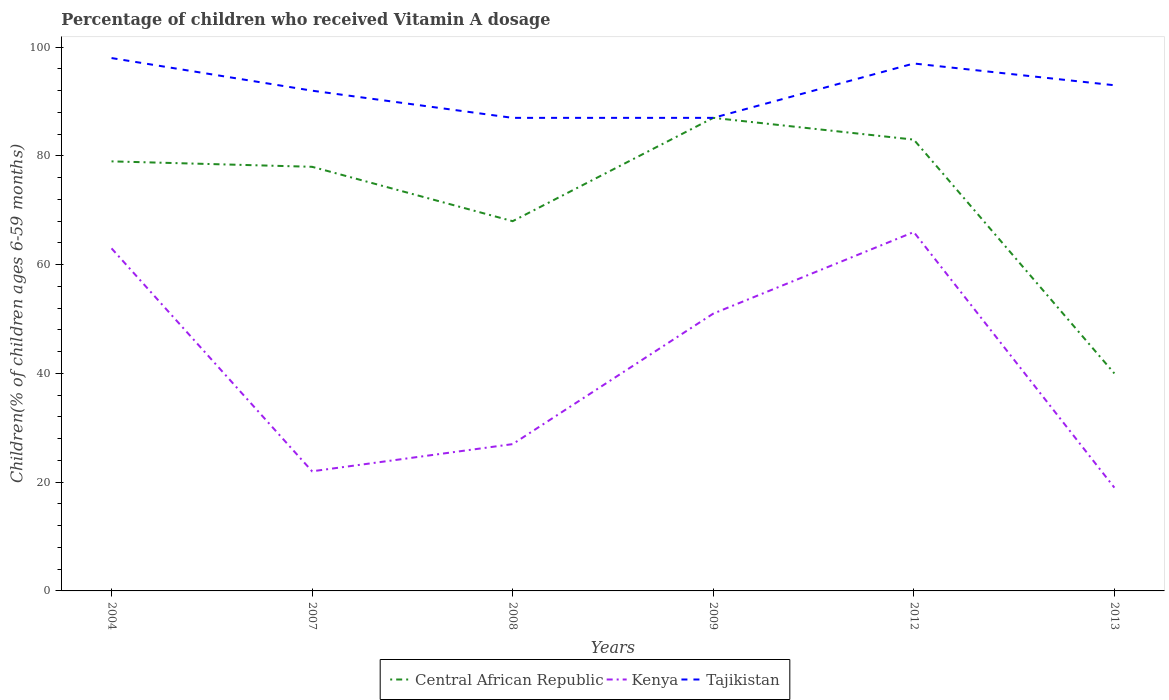How many different coloured lines are there?
Make the answer very short. 3. Does the line corresponding to Tajikistan intersect with the line corresponding to Kenya?
Keep it short and to the point. No. Is the number of lines equal to the number of legend labels?
Provide a short and direct response. Yes. What is the total percentage of children who received Vitamin A dosage in Central African Republic in the graph?
Offer a terse response. 10. What is the difference between the highest and the second highest percentage of children who received Vitamin A dosage in Central African Republic?
Your response must be concise. 47. What is the difference between the highest and the lowest percentage of children who received Vitamin A dosage in Kenya?
Provide a short and direct response. 3. Does the graph contain grids?
Provide a short and direct response. No. Where does the legend appear in the graph?
Your answer should be very brief. Bottom center. What is the title of the graph?
Keep it short and to the point. Percentage of children who received Vitamin A dosage. Does "Malta" appear as one of the legend labels in the graph?
Give a very brief answer. No. What is the label or title of the Y-axis?
Provide a short and direct response. Children(% of children ages 6-59 months). What is the Children(% of children ages 6-59 months) of Central African Republic in 2004?
Your answer should be compact. 79. What is the Children(% of children ages 6-59 months) of Kenya in 2004?
Ensure brevity in your answer.  63. What is the Children(% of children ages 6-59 months) in Kenya in 2007?
Provide a short and direct response. 22. What is the Children(% of children ages 6-59 months) in Tajikistan in 2007?
Make the answer very short. 92. What is the Children(% of children ages 6-59 months) of Central African Republic in 2008?
Your answer should be compact. 68. What is the Children(% of children ages 6-59 months) in Kenya in 2008?
Ensure brevity in your answer.  27. What is the Children(% of children ages 6-59 months) of Tajikistan in 2008?
Offer a terse response. 87. What is the Children(% of children ages 6-59 months) in Central African Republic in 2009?
Provide a succinct answer. 87. What is the Children(% of children ages 6-59 months) in Kenya in 2009?
Your response must be concise. 51. What is the Children(% of children ages 6-59 months) in Kenya in 2012?
Keep it short and to the point. 66. What is the Children(% of children ages 6-59 months) in Tajikistan in 2012?
Give a very brief answer. 97. What is the Children(% of children ages 6-59 months) in Kenya in 2013?
Provide a short and direct response. 19. What is the Children(% of children ages 6-59 months) of Tajikistan in 2013?
Provide a succinct answer. 93. Across all years, what is the maximum Children(% of children ages 6-59 months) of Kenya?
Offer a terse response. 66. Across all years, what is the maximum Children(% of children ages 6-59 months) of Tajikistan?
Your answer should be compact. 98. Across all years, what is the minimum Children(% of children ages 6-59 months) of Kenya?
Your response must be concise. 19. Across all years, what is the minimum Children(% of children ages 6-59 months) in Tajikistan?
Your answer should be compact. 87. What is the total Children(% of children ages 6-59 months) in Central African Republic in the graph?
Give a very brief answer. 435. What is the total Children(% of children ages 6-59 months) of Kenya in the graph?
Your answer should be compact. 248. What is the total Children(% of children ages 6-59 months) in Tajikistan in the graph?
Provide a succinct answer. 554. What is the difference between the Children(% of children ages 6-59 months) of Central African Republic in 2004 and that in 2008?
Offer a very short reply. 11. What is the difference between the Children(% of children ages 6-59 months) in Tajikistan in 2004 and that in 2008?
Your response must be concise. 11. What is the difference between the Children(% of children ages 6-59 months) of Kenya in 2004 and that in 2009?
Your answer should be compact. 12. What is the difference between the Children(% of children ages 6-59 months) in Central African Republic in 2004 and that in 2012?
Offer a very short reply. -4. What is the difference between the Children(% of children ages 6-59 months) of Central African Republic in 2007 and that in 2008?
Make the answer very short. 10. What is the difference between the Children(% of children ages 6-59 months) of Kenya in 2007 and that in 2008?
Keep it short and to the point. -5. What is the difference between the Children(% of children ages 6-59 months) in Tajikistan in 2007 and that in 2008?
Your response must be concise. 5. What is the difference between the Children(% of children ages 6-59 months) of Kenya in 2007 and that in 2009?
Your answer should be compact. -29. What is the difference between the Children(% of children ages 6-59 months) of Central African Republic in 2007 and that in 2012?
Offer a terse response. -5. What is the difference between the Children(% of children ages 6-59 months) of Kenya in 2007 and that in 2012?
Ensure brevity in your answer.  -44. What is the difference between the Children(% of children ages 6-59 months) in Tajikistan in 2007 and that in 2012?
Keep it short and to the point. -5. What is the difference between the Children(% of children ages 6-59 months) in Kenya in 2007 and that in 2013?
Your response must be concise. 3. What is the difference between the Children(% of children ages 6-59 months) in Kenya in 2008 and that in 2009?
Your answer should be compact. -24. What is the difference between the Children(% of children ages 6-59 months) in Tajikistan in 2008 and that in 2009?
Your response must be concise. 0. What is the difference between the Children(% of children ages 6-59 months) in Kenya in 2008 and that in 2012?
Provide a succinct answer. -39. What is the difference between the Children(% of children ages 6-59 months) in Kenya in 2008 and that in 2013?
Ensure brevity in your answer.  8. What is the difference between the Children(% of children ages 6-59 months) in Central African Republic in 2009 and that in 2012?
Provide a short and direct response. 4. What is the difference between the Children(% of children ages 6-59 months) of Kenya in 2009 and that in 2012?
Make the answer very short. -15. What is the difference between the Children(% of children ages 6-59 months) of Tajikistan in 2009 and that in 2013?
Offer a terse response. -6. What is the difference between the Children(% of children ages 6-59 months) of Central African Republic in 2012 and that in 2013?
Make the answer very short. 43. What is the difference between the Children(% of children ages 6-59 months) of Tajikistan in 2012 and that in 2013?
Keep it short and to the point. 4. What is the difference between the Children(% of children ages 6-59 months) of Central African Republic in 2004 and the Children(% of children ages 6-59 months) of Kenya in 2007?
Offer a terse response. 57. What is the difference between the Children(% of children ages 6-59 months) of Central African Republic in 2004 and the Children(% of children ages 6-59 months) of Tajikistan in 2007?
Offer a very short reply. -13. What is the difference between the Children(% of children ages 6-59 months) of Kenya in 2004 and the Children(% of children ages 6-59 months) of Tajikistan in 2008?
Make the answer very short. -24. What is the difference between the Children(% of children ages 6-59 months) in Central African Republic in 2004 and the Children(% of children ages 6-59 months) in Kenya in 2009?
Your answer should be very brief. 28. What is the difference between the Children(% of children ages 6-59 months) of Kenya in 2004 and the Children(% of children ages 6-59 months) of Tajikistan in 2009?
Provide a short and direct response. -24. What is the difference between the Children(% of children ages 6-59 months) of Central African Republic in 2004 and the Children(% of children ages 6-59 months) of Kenya in 2012?
Your response must be concise. 13. What is the difference between the Children(% of children ages 6-59 months) in Central African Republic in 2004 and the Children(% of children ages 6-59 months) in Tajikistan in 2012?
Your answer should be compact. -18. What is the difference between the Children(% of children ages 6-59 months) in Kenya in 2004 and the Children(% of children ages 6-59 months) in Tajikistan in 2012?
Offer a very short reply. -34. What is the difference between the Children(% of children ages 6-59 months) of Central African Republic in 2004 and the Children(% of children ages 6-59 months) of Kenya in 2013?
Ensure brevity in your answer.  60. What is the difference between the Children(% of children ages 6-59 months) of Central African Republic in 2007 and the Children(% of children ages 6-59 months) of Kenya in 2008?
Make the answer very short. 51. What is the difference between the Children(% of children ages 6-59 months) of Kenya in 2007 and the Children(% of children ages 6-59 months) of Tajikistan in 2008?
Your response must be concise. -65. What is the difference between the Children(% of children ages 6-59 months) of Central African Republic in 2007 and the Children(% of children ages 6-59 months) of Tajikistan in 2009?
Offer a very short reply. -9. What is the difference between the Children(% of children ages 6-59 months) in Kenya in 2007 and the Children(% of children ages 6-59 months) in Tajikistan in 2009?
Keep it short and to the point. -65. What is the difference between the Children(% of children ages 6-59 months) in Central African Republic in 2007 and the Children(% of children ages 6-59 months) in Kenya in 2012?
Offer a terse response. 12. What is the difference between the Children(% of children ages 6-59 months) in Kenya in 2007 and the Children(% of children ages 6-59 months) in Tajikistan in 2012?
Your response must be concise. -75. What is the difference between the Children(% of children ages 6-59 months) in Central African Republic in 2007 and the Children(% of children ages 6-59 months) in Tajikistan in 2013?
Keep it short and to the point. -15. What is the difference between the Children(% of children ages 6-59 months) of Kenya in 2007 and the Children(% of children ages 6-59 months) of Tajikistan in 2013?
Your response must be concise. -71. What is the difference between the Children(% of children ages 6-59 months) in Central African Republic in 2008 and the Children(% of children ages 6-59 months) in Tajikistan in 2009?
Your answer should be very brief. -19. What is the difference between the Children(% of children ages 6-59 months) of Kenya in 2008 and the Children(% of children ages 6-59 months) of Tajikistan in 2009?
Offer a terse response. -60. What is the difference between the Children(% of children ages 6-59 months) in Kenya in 2008 and the Children(% of children ages 6-59 months) in Tajikistan in 2012?
Provide a short and direct response. -70. What is the difference between the Children(% of children ages 6-59 months) of Central African Republic in 2008 and the Children(% of children ages 6-59 months) of Kenya in 2013?
Your answer should be very brief. 49. What is the difference between the Children(% of children ages 6-59 months) of Central African Republic in 2008 and the Children(% of children ages 6-59 months) of Tajikistan in 2013?
Give a very brief answer. -25. What is the difference between the Children(% of children ages 6-59 months) in Kenya in 2008 and the Children(% of children ages 6-59 months) in Tajikistan in 2013?
Your answer should be very brief. -66. What is the difference between the Children(% of children ages 6-59 months) in Central African Republic in 2009 and the Children(% of children ages 6-59 months) in Kenya in 2012?
Offer a very short reply. 21. What is the difference between the Children(% of children ages 6-59 months) of Central African Republic in 2009 and the Children(% of children ages 6-59 months) of Tajikistan in 2012?
Make the answer very short. -10. What is the difference between the Children(% of children ages 6-59 months) in Kenya in 2009 and the Children(% of children ages 6-59 months) in Tajikistan in 2012?
Ensure brevity in your answer.  -46. What is the difference between the Children(% of children ages 6-59 months) in Kenya in 2009 and the Children(% of children ages 6-59 months) in Tajikistan in 2013?
Ensure brevity in your answer.  -42. What is the difference between the Children(% of children ages 6-59 months) in Central African Republic in 2012 and the Children(% of children ages 6-59 months) in Tajikistan in 2013?
Offer a very short reply. -10. What is the difference between the Children(% of children ages 6-59 months) of Kenya in 2012 and the Children(% of children ages 6-59 months) of Tajikistan in 2013?
Your answer should be very brief. -27. What is the average Children(% of children ages 6-59 months) in Central African Republic per year?
Your response must be concise. 72.5. What is the average Children(% of children ages 6-59 months) in Kenya per year?
Ensure brevity in your answer.  41.33. What is the average Children(% of children ages 6-59 months) of Tajikistan per year?
Your answer should be compact. 92.33. In the year 2004, what is the difference between the Children(% of children ages 6-59 months) in Central African Republic and Children(% of children ages 6-59 months) in Kenya?
Offer a terse response. 16. In the year 2004, what is the difference between the Children(% of children ages 6-59 months) of Kenya and Children(% of children ages 6-59 months) of Tajikistan?
Your answer should be compact. -35. In the year 2007, what is the difference between the Children(% of children ages 6-59 months) in Kenya and Children(% of children ages 6-59 months) in Tajikistan?
Provide a succinct answer. -70. In the year 2008, what is the difference between the Children(% of children ages 6-59 months) of Kenya and Children(% of children ages 6-59 months) of Tajikistan?
Give a very brief answer. -60. In the year 2009, what is the difference between the Children(% of children ages 6-59 months) of Central African Republic and Children(% of children ages 6-59 months) of Tajikistan?
Provide a short and direct response. 0. In the year 2009, what is the difference between the Children(% of children ages 6-59 months) of Kenya and Children(% of children ages 6-59 months) of Tajikistan?
Offer a terse response. -36. In the year 2012, what is the difference between the Children(% of children ages 6-59 months) of Central African Republic and Children(% of children ages 6-59 months) of Kenya?
Your answer should be very brief. 17. In the year 2012, what is the difference between the Children(% of children ages 6-59 months) in Central African Republic and Children(% of children ages 6-59 months) in Tajikistan?
Your answer should be very brief. -14. In the year 2012, what is the difference between the Children(% of children ages 6-59 months) in Kenya and Children(% of children ages 6-59 months) in Tajikistan?
Offer a very short reply. -31. In the year 2013, what is the difference between the Children(% of children ages 6-59 months) in Central African Republic and Children(% of children ages 6-59 months) in Tajikistan?
Keep it short and to the point. -53. In the year 2013, what is the difference between the Children(% of children ages 6-59 months) in Kenya and Children(% of children ages 6-59 months) in Tajikistan?
Ensure brevity in your answer.  -74. What is the ratio of the Children(% of children ages 6-59 months) in Central African Republic in 2004 to that in 2007?
Keep it short and to the point. 1.01. What is the ratio of the Children(% of children ages 6-59 months) in Kenya in 2004 to that in 2007?
Offer a very short reply. 2.86. What is the ratio of the Children(% of children ages 6-59 months) of Tajikistan in 2004 to that in 2007?
Provide a short and direct response. 1.07. What is the ratio of the Children(% of children ages 6-59 months) of Central African Republic in 2004 to that in 2008?
Your answer should be very brief. 1.16. What is the ratio of the Children(% of children ages 6-59 months) in Kenya in 2004 to that in 2008?
Make the answer very short. 2.33. What is the ratio of the Children(% of children ages 6-59 months) of Tajikistan in 2004 to that in 2008?
Offer a very short reply. 1.13. What is the ratio of the Children(% of children ages 6-59 months) in Central African Republic in 2004 to that in 2009?
Give a very brief answer. 0.91. What is the ratio of the Children(% of children ages 6-59 months) in Kenya in 2004 to that in 2009?
Keep it short and to the point. 1.24. What is the ratio of the Children(% of children ages 6-59 months) in Tajikistan in 2004 to that in 2009?
Make the answer very short. 1.13. What is the ratio of the Children(% of children ages 6-59 months) of Central African Republic in 2004 to that in 2012?
Provide a short and direct response. 0.95. What is the ratio of the Children(% of children ages 6-59 months) of Kenya in 2004 to that in 2012?
Ensure brevity in your answer.  0.95. What is the ratio of the Children(% of children ages 6-59 months) of Tajikistan in 2004 to that in 2012?
Offer a very short reply. 1.01. What is the ratio of the Children(% of children ages 6-59 months) of Central African Republic in 2004 to that in 2013?
Give a very brief answer. 1.98. What is the ratio of the Children(% of children ages 6-59 months) in Kenya in 2004 to that in 2013?
Give a very brief answer. 3.32. What is the ratio of the Children(% of children ages 6-59 months) in Tajikistan in 2004 to that in 2013?
Your answer should be very brief. 1.05. What is the ratio of the Children(% of children ages 6-59 months) of Central African Republic in 2007 to that in 2008?
Ensure brevity in your answer.  1.15. What is the ratio of the Children(% of children ages 6-59 months) in Kenya in 2007 to that in 2008?
Provide a short and direct response. 0.81. What is the ratio of the Children(% of children ages 6-59 months) in Tajikistan in 2007 to that in 2008?
Provide a short and direct response. 1.06. What is the ratio of the Children(% of children ages 6-59 months) in Central African Republic in 2007 to that in 2009?
Offer a very short reply. 0.9. What is the ratio of the Children(% of children ages 6-59 months) in Kenya in 2007 to that in 2009?
Keep it short and to the point. 0.43. What is the ratio of the Children(% of children ages 6-59 months) in Tajikistan in 2007 to that in 2009?
Your answer should be very brief. 1.06. What is the ratio of the Children(% of children ages 6-59 months) in Central African Republic in 2007 to that in 2012?
Make the answer very short. 0.94. What is the ratio of the Children(% of children ages 6-59 months) in Kenya in 2007 to that in 2012?
Make the answer very short. 0.33. What is the ratio of the Children(% of children ages 6-59 months) of Tajikistan in 2007 to that in 2012?
Provide a succinct answer. 0.95. What is the ratio of the Children(% of children ages 6-59 months) of Central African Republic in 2007 to that in 2013?
Your answer should be compact. 1.95. What is the ratio of the Children(% of children ages 6-59 months) in Kenya in 2007 to that in 2013?
Give a very brief answer. 1.16. What is the ratio of the Children(% of children ages 6-59 months) in Central African Republic in 2008 to that in 2009?
Give a very brief answer. 0.78. What is the ratio of the Children(% of children ages 6-59 months) in Kenya in 2008 to that in 2009?
Your answer should be compact. 0.53. What is the ratio of the Children(% of children ages 6-59 months) of Central African Republic in 2008 to that in 2012?
Keep it short and to the point. 0.82. What is the ratio of the Children(% of children ages 6-59 months) in Kenya in 2008 to that in 2012?
Offer a terse response. 0.41. What is the ratio of the Children(% of children ages 6-59 months) of Tajikistan in 2008 to that in 2012?
Make the answer very short. 0.9. What is the ratio of the Children(% of children ages 6-59 months) of Kenya in 2008 to that in 2013?
Provide a succinct answer. 1.42. What is the ratio of the Children(% of children ages 6-59 months) of Tajikistan in 2008 to that in 2013?
Your response must be concise. 0.94. What is the ratio of the Children(% of children ages 6-59 months) in Central African Republic in 2009 to that in 2012?
Your answer should be compact. 1.05. What is the ratio of the Children(% of children ages 6-59 months) of Kenya in 2009 to that in 2012?
Give a very brief answer. 0.77. What is the ratio of the Children(% of children ages 6-59 months) of Tajikistan in 2009 to that in 2012?
Give a very brief answer. 0.9. What is the ratio of the Children(% of children ages 6-59 months) in Central African Republic in 2009 to that in 2013?
Provide a succinct answer. 2.17. What is the ratio of the Children(% of children ages 6-59 months) of Kenya in 2009 to that in 2013?
Offer a very short reply. 2.68. What is the ratio of the Children(% of children ages 6-59 months) in Tajikistan in 2009 to that in 2013?
Keep it short and to the point. 0.94. What is the ratio of the Children(% of children ages 6-59 months) of Central African Republic in 2012 to that in 2013?
Your answer should be compact. 2.08. What is the ratio of the Children(% of children ages 6-59 months) in Kenya in 2012 to that in 2013?
Make the answer very short. 3.47. What is the ratio of the Children(% of children ages 6-59 months) in Tajikistan in 2012 to that in 2013?
Give a very brief answer. 1.04. What is the difference between the highest and the second highest Children(% of children ages 6-59 months) in Central African Republic?
Your answer should be compact. 4. What is the difference between the highest and the second highest Children(% of children ages 6-59 months) of Kenya?
Your answer should be very brief. 3. What is the difference between the highest and the second highest Children(% of children ages 6-59 months) of Tajikistan?
Keep it short and to the point. 1. What is the difference between the highest and the lowest Children(% of children ages 6-59 months) of Central African Republic?
Keep it short and to the point. 47. What is the difference between the highest and the lowest Children(% of children ages 6-59 months) of Tajikistan?
Your answer should be very brief. 11. 